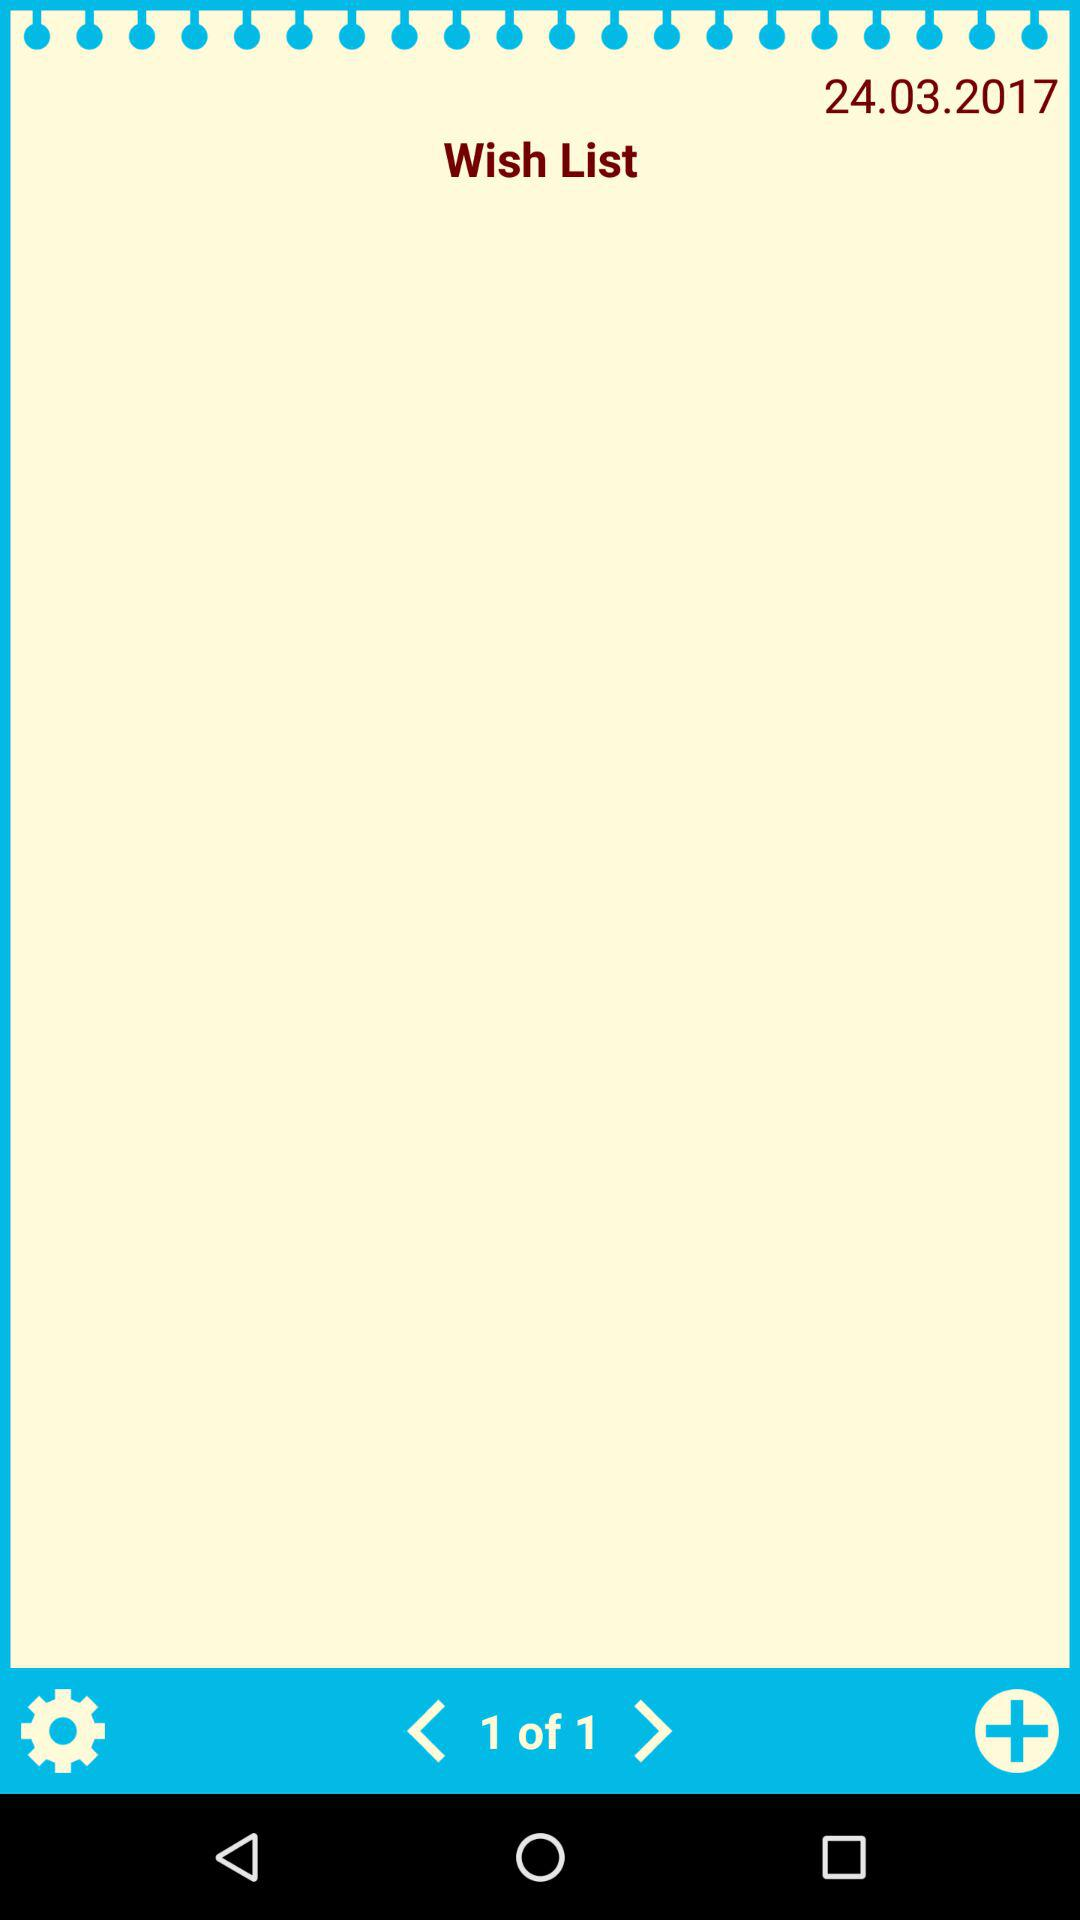How many total pages are there? There is 1 page. 